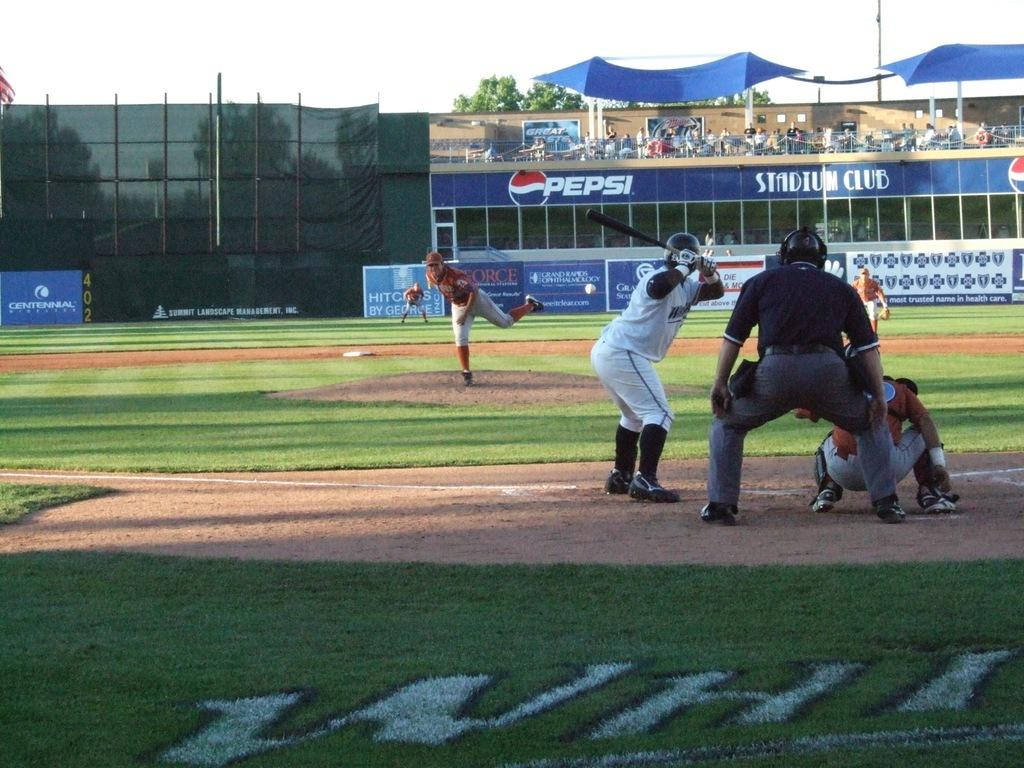<image>
Give a short and clear explanation of the subsequent image. Baseball player getting ready to bat in a stadium that has a PEPSI ad. 